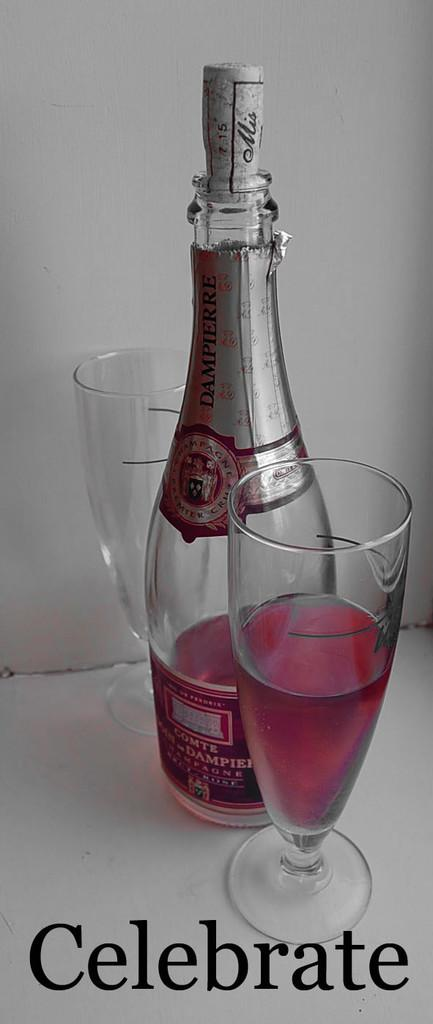<image>
Render a clear and concise summary of the photo. A bottle of pink Dampierre Champagne next to two glasses. 